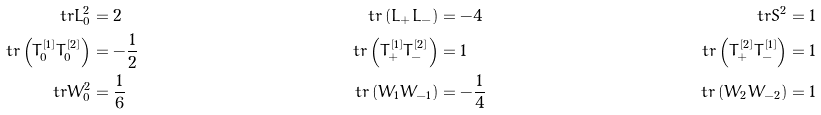Convert formula to latex. <formula><loc_0><loc_0><loc_500><loc_500>\ t r L _ { 0 } ^ { 2 } & = 2 & \ t r \left ( L _ { + } L _ { - } \right ) & = - 4 & \ t r S ^ { 2 } & = 1 \\ \ t r \left ( T _ { 0 } ^ { [ 1 ] } T _ { 0 } ^ { [ 2 ] } \right ) & = - \frac { 1 } { 2 } & \ t r \left ( T _ { + } ^ { [ 1 ] } T _ { - } ^ { [ 2 ] } \right ) & = 1 & \ t r \left ( T _ { + } ^ { [ 2 ] } T _ { - } ^ { [ 1 ] } \right ) & = 1 \\ \ t r W _ { 0 } ^ { 2 } & = \frac { 1 } { 6 } & \ t r \left ( W _ { 1 } W _ { - 1 } \right ) & = - \frac { 1 } { 4 } & \ t r \left ( W _ { 2 } W _ { - 2 } \right ) & = 1</formula> 